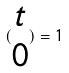<formula> <loc_0><loc_0><loc_500><loc_500>( \begin{matrix} t \\ 0 \end{matrix} ) = 1</formula> 